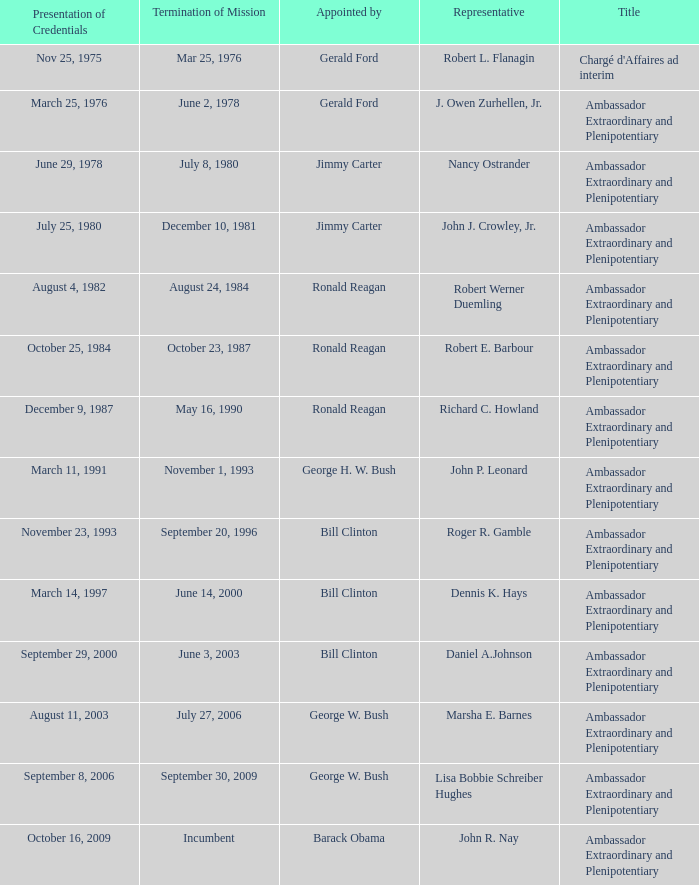Who appointed the representative that had a Presentation of Credentials on March 25, 1976? Gerald Ford. 